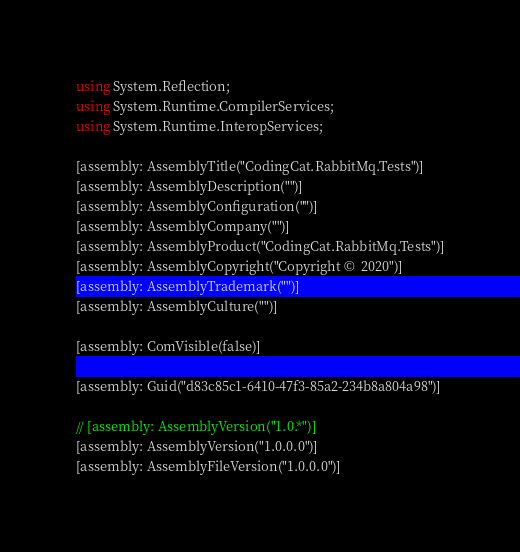<code> <loc_0><loc_0><loc_500><loc_500><_C#_>using System.Reflection;
using System.Runtime.CompilerServices;
using System.Runtime.InteropServices;

[assembly: AssemblyTitle("CodingCat.RabbitMq.Tests")]
[assembly: AssemblyDescription("")]
[assembly: AssemblyConfiguration("")]
[assembly: AssemblyCompany("")]
[assembly: AssemblyProduct("CodingCat.RabbitMq.Tests")]
[assembly: AssemblyCopyright("Copyright ©  2020")]
[assembly: AssemblyTrademark("")]
[assembly: AssemblyCulture("")]

[assembly: ComVisible(false)]

[assembly: Guid("d83c85c1-6410-47f3-85a2-234b8a804a98")]

// [assembly: AssemblyVersion("1.0.*")]
[assembly: AssemblyVersion("1.0.0.0")]
[assembly: AssemblyFileVersion("1.0.0.0")]
</code> 